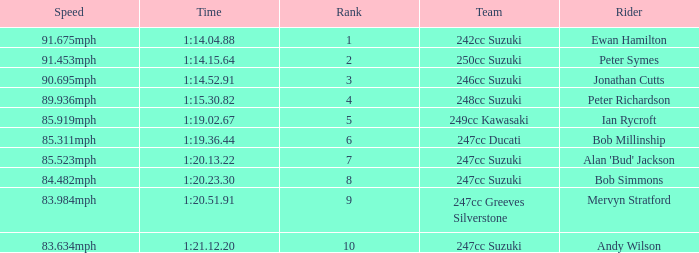Would you mind parsing the complete table? {'header': ['Speed', 'Time', 'Rank', 'Team', 'Rider'], 'rows': [['91.675mph', '1:14.04.88', '1', '242cc Suzuki', 'Ewan Hamilton'], ['91.453mph', '1:14.15.64', '2', '250cc Suzuki', 'Peter Symes'], ['90.695mph', '1:14.52.91', '3', '246cc Suzuki', 'Jonathan Cutts'], ['89.936mph', '1:15.30.82', '4', '248cc Suzuki', 'Peter Richardson'], ['85.919mph', '1:19.02.67', '5', '249cc Kawasaki', 'Ian Rycroft'], ['85.311mph', '1:19.36.44', '6', '247cc Ducati', 'Bob Millinship'], ['85.523mph', '1:20.13.22', '7', '247cc Suzuki', "Alan 'Bud' Jackson"], ['84.482mph', '1:20.23.30', '8', '247cc Suzuki', 'Bob Simmons'], ['83.984mph', '1:20.51.91', '9', '247cc Greeves Silverstone', 'Mervyn Stratford'], ['83.634mph', '1:21.12.20', '10', '247cc Suzuki', 'Andy Wilson']]} Which team had a rank under 4 with a time of 1:14.04.88? 242cc Suzuki. 